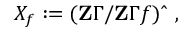Convert formula to latex. <formula><loc_0><loc_0><loc_500><loc_500>X _ { f } \colon = ( Z \Gamma / Z \Gamma f ) { \widehat { \ } } \ ,</formula> 